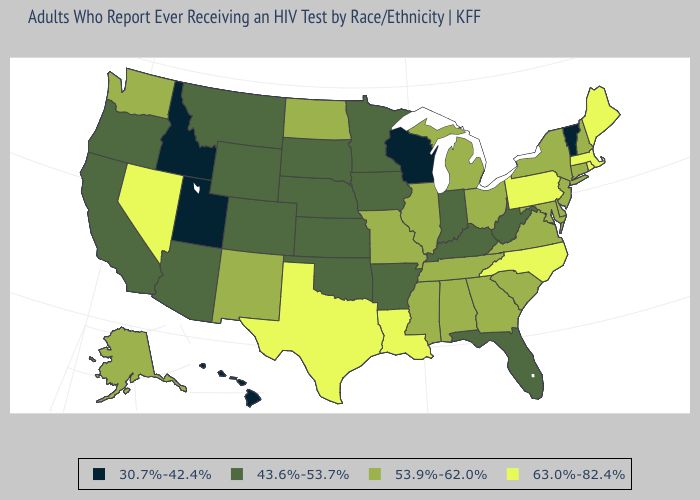What is the value of West Virginia?
Answer briefly. 43.6%-53.7%. Does Hawaii have a higher value than Georgia?
Concise answer only. No. What is the value of Kentucky?
Short answer required. 43.6%-53.7%. What is the highest value in the South ?
Give a very brief answer. 63.0%-82.4%. Does Wisconsin have the lowest value in the USA?
Short answer required. Yes. Name the states that have a value in the range 63.0%-82.4%?
Keep it brief. Louisiana, Maine, Massachusetts, Nevada, North Carolina, Pennsylvania, Rhode Island, Texas. Name the states that have a value in the range 53.9%-62.0%?
Write a very short answer. Alabama, Alaska, Connecticut, Delaware, Georgia, Illinois, Maryland, Michigan, Mississippi, Missouri, New Hampshire, New Jersey, New Mexico, New York, North Dakota, Ohio, South Carolina, Tennessee, Virginia, Washington. Does Rhode Island have the highest value in the USA?
Write a very short answer. Yes. Does Alabama have the lowest value in the South?
Give a very brief answer. No. What is the value of Michigan?
Concise answer only. 53.9%-62.0%. What is the value of Oklahoma?
Short answer required. 43.6%-53.7%. Name the states that have a value in the range 53.9%-62.0%?
Be succinct. Alabama, Alaska, Connecticut, Delaware, Georgia, Illinois, Maryland, Michigan, Mississippi, Missouri, New Hampshire, New Jersey, New Mexico, New York, North Dakota, Ohio, South Carolina, Tennessee, Virginia, Washington. What is the value of Connecticut?
Write a very short answer. 53.9%-62.0%. Which states have the lowest value in the USA?
Quick response, please. Hawaii, Idaho, Utah, Vermont, Wisconsin. Name the states that have a value in the range 43.6%-53.7%?
Be succinct. Arizona, Arkansas, California, Colorado, Florida, Indiana, Iowa, Kansas, Kentucky, Minnesota, Montana, Nebraska, Oklahoma, Oregon, South Dakota, West Virginia, Wyoming. 